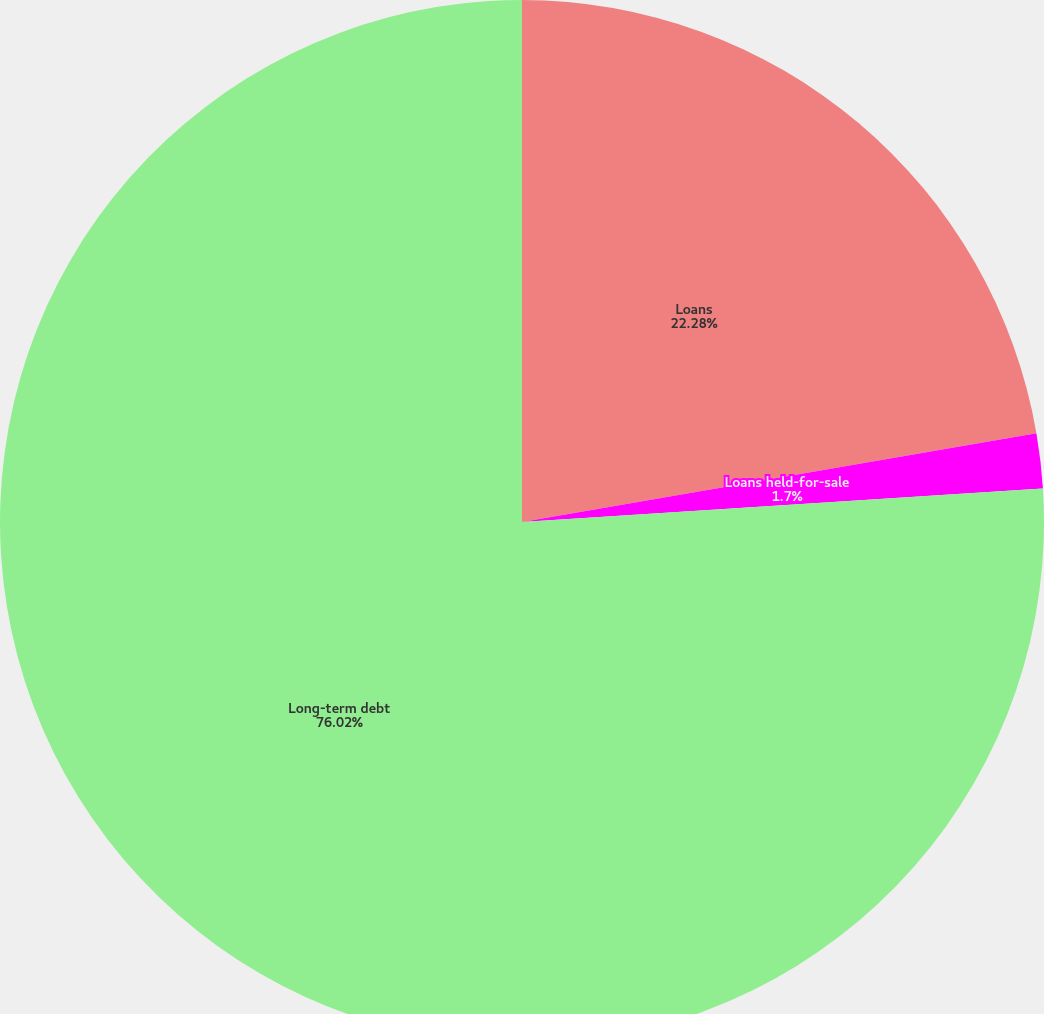Convert chart. <chart><loc_0><loc_0><loc_500><loc_500><pie_chart><fcel>Loans<fcel>Loans held-for-sale<fcel>Long-term debt<nl><fcel>22.28%<fcel>1.7%<fcel>76.02%<nl></chart> 